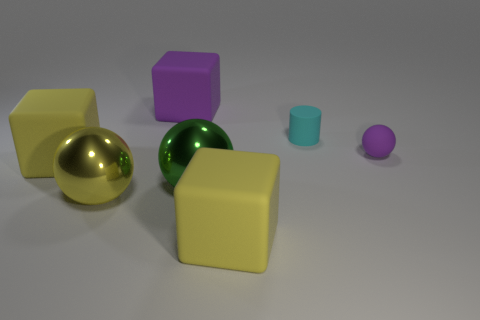Subtract all red spheres. Subtract all blue cubes. How many spheres are left? 3 Add 2 metal cylinders. How many objects exist? 9 Subtract all blocks. How many objects are left? 4 Subtract all tiny cyan shiny objects. Subtract all purple things. How many objects are left? 5 Add 4 yellow objects. How many yellow objects are left? 7 Add 3 small purple matte things. How many small purple matte things exist? 4 Subtract 0 yellow cylinders. How many objects are left? 7 